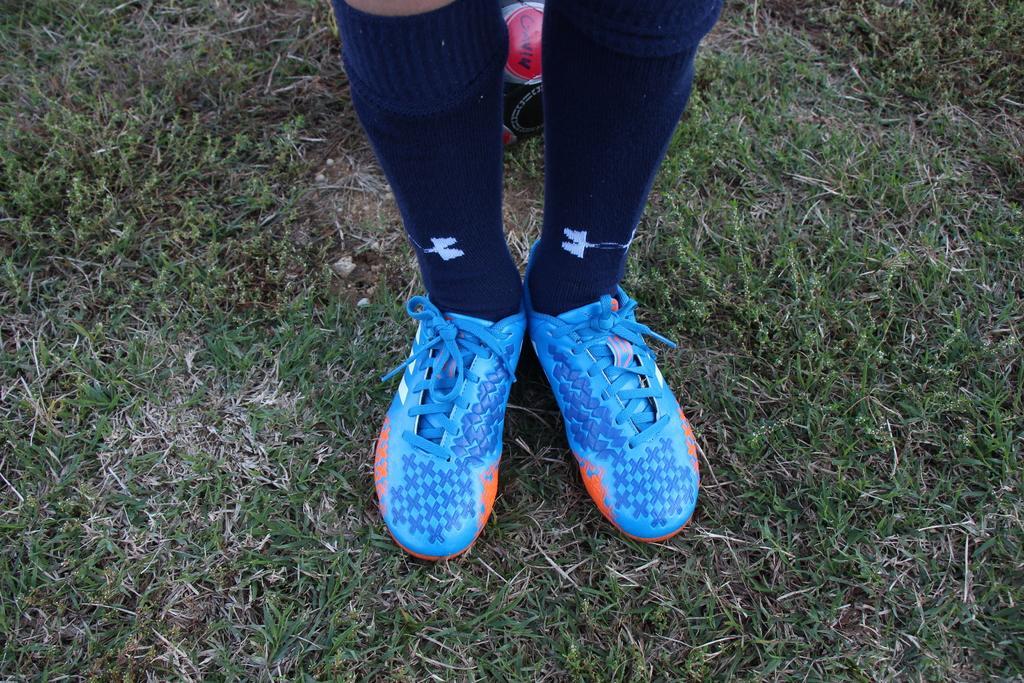Can you describe this image briefly? In this image, we can see the legs of a person who is wearing shoes, there's grass on the ground. 